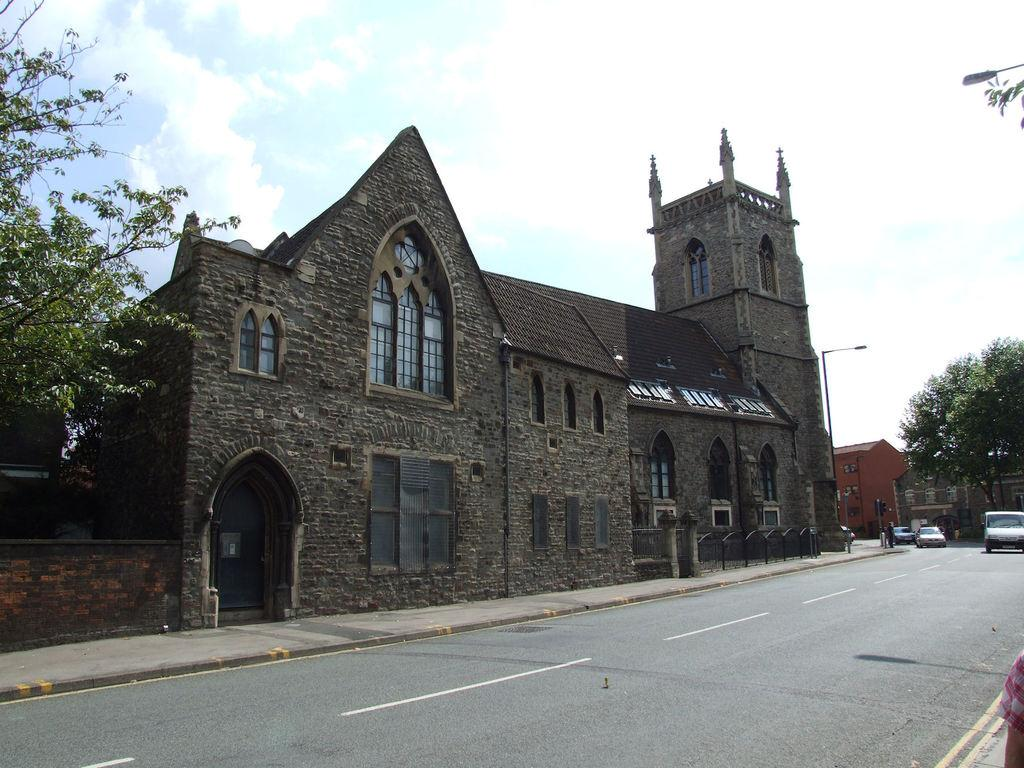What type of vehicles can be seen on the road in the image? There are cars on the road in the image. What other elements can be seen in the image besides the cars? Trees, buildings with windows, and the sky are visible in the image. Can you describe the sky in the image? The sky is visible in the background of the image, and clouds are present in it. What type of curtain is hanging in the window of the building in the image? There is no curtain visible in the image; only the windows of the buildings are present. What type of pain is being experienced by the cars in the image? Cars do not experience pain, so this question cannot be answered. 